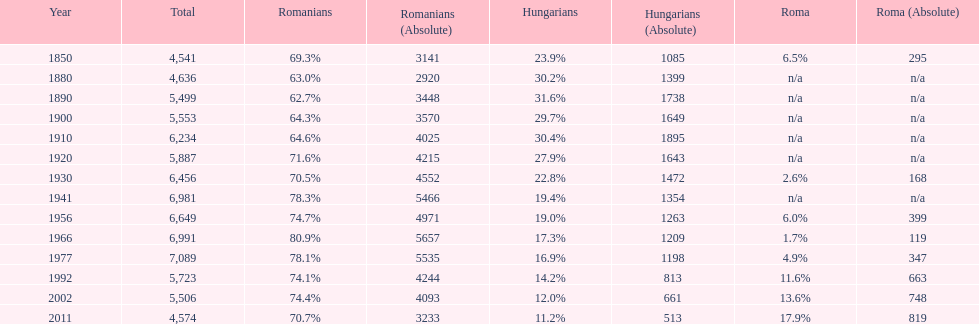In what year was there the largest percentage of hungarians? 1890. 